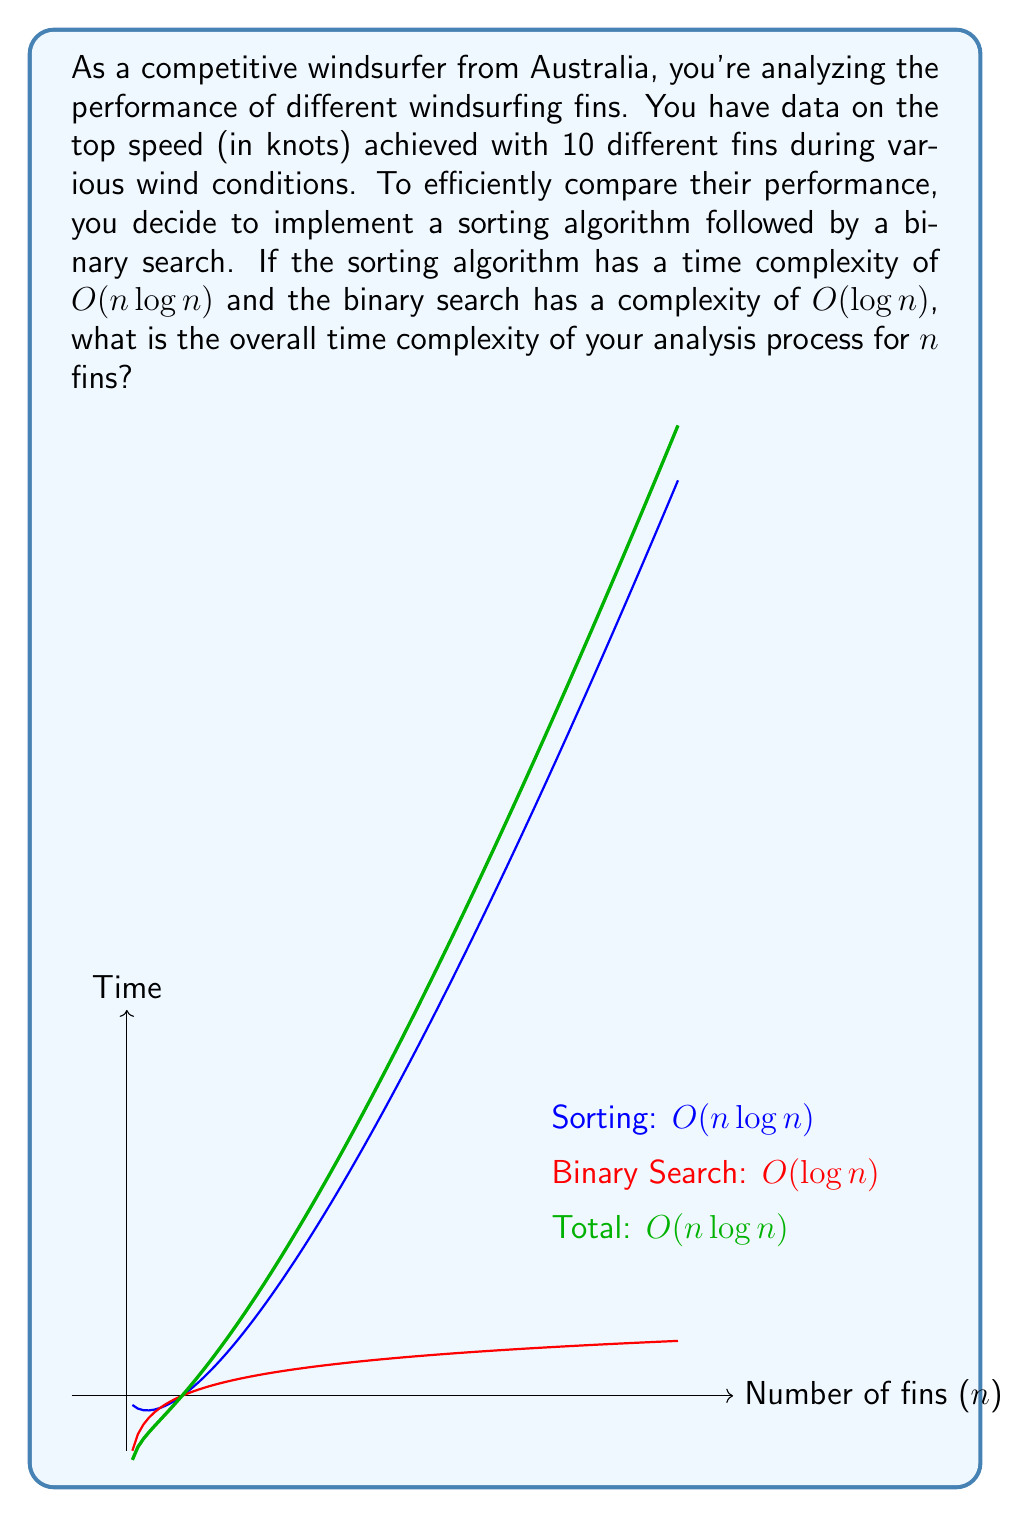Show me your answer to this math problem. Let's break this down step-by-step:

1) First, we need to consider the time complexity of each part of the process:
   - Sorting algorithm: $O(n \log n)$
   - Binary search: $O(\log n)$

2) When we have multiple operations, we add their complexities. However, we only keep the dominant term (the term that grows the fastest as n increases).

3) In this case, we have:
   $O(n \log n) + O(\log n)$

4) As $n$ grows, $n \log n$ grows much faster than $\log n$. Therefore, $O(\log n)$ becomes insignificant compared to $O(n \log n)$.

5) In big O notation, we can drop lower-order terms. So:
   $O(n \log n) + O(\log n) = O(n \log n)$

6) This means that the sorting step dominates the overall time complexity, and the binary search doesn't significantly affect the overall complexity for large $n$.

7) The graph in the question visually demonstrates this concept. The green line (total complexity) closely follows the blue line (sorting complexity) as $n$ increases, while the red line (binary search complexity) grows much more slowly.

Therefore, the overall time complexity of your analysis process remains $O(n \log n)$.
Answer: $O(n \log n)$ 